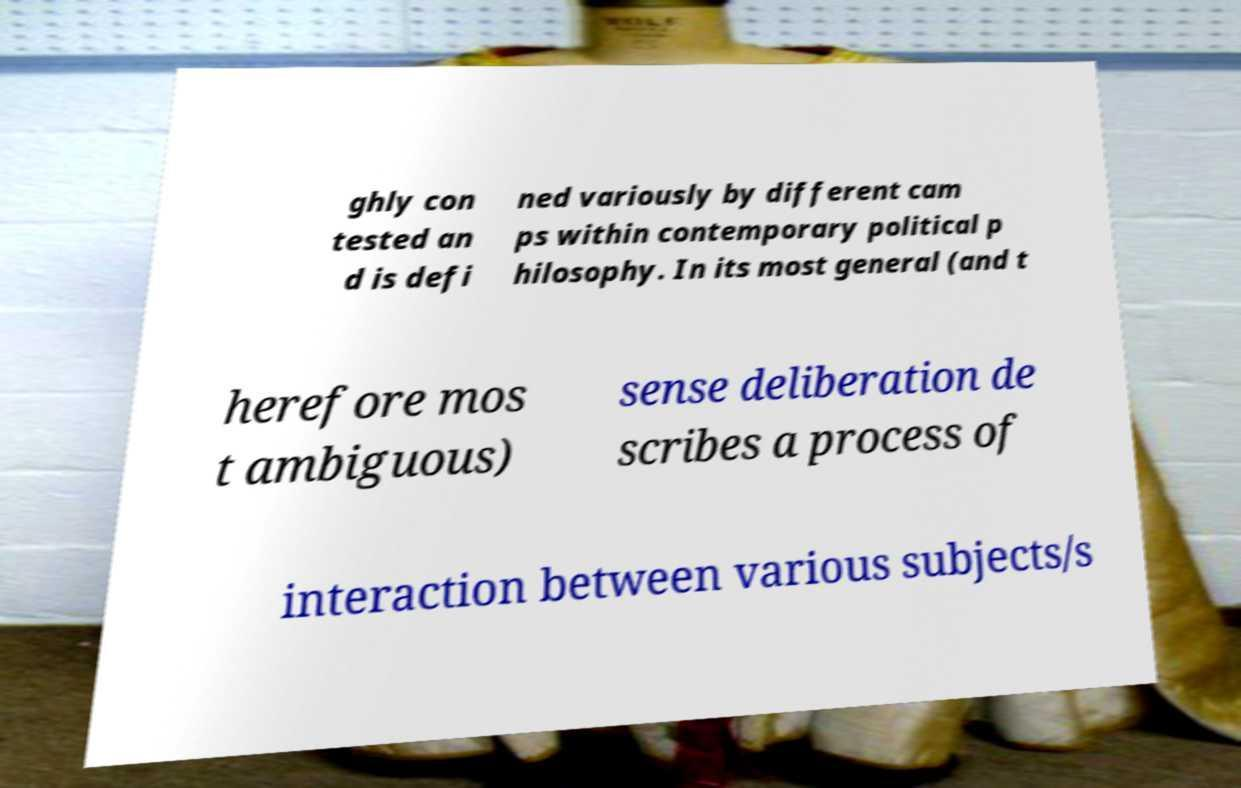Can you accurately transcribe the text from the provided image for me? ghly con tested an d is defi ned variously by different cam ps within contemporary political p hilosophy. In its most general (and t herefore mos t ambiguous) sense deliberation de scribes a process of interaction between various subjects/s 